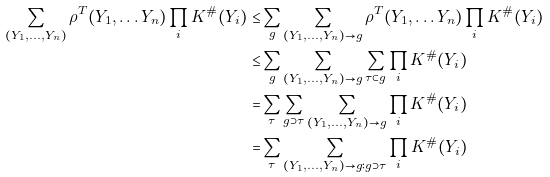Convert formula to latex. <formula><loc_0><loc_0><loc_500><loc_500>\sum _ { ( Y _ { 1 } , \dots , Y _ { n } ) } \rho ^ { T } ( Y _ { 1 } , \dots Y _ { n } ) \prod _ { i } K ^ { \# } ( Y _ { i } ) \leq & \sum _ { g } \sum _ { ( Y _ { 1 } , \dots , Y _ { n } ) \to g } \rho ^ { T } ( Y _ { 1 } , \dots Y _ { n } ) \prod _ { i } K ^ { \# } ( Y _ { i } ) \\ \leq & \sum _ { g } \sum _ { ( Y _ { 1 } , \dots , Y _ { n } ) \to g } \sum _ { \tau \subset g } \prod _ { i } K ^ { \# } ( Y _ { i } ) \\ = & \sum _ { \tau } \sum _ { g \supset \tau } \sum _ { ( Y _ { 1 } , \dots , Y _ { n } ) \to g } \prod _ { i } K ^ { \# } ( Y _ { i } ) \\ = & \sum _ { \tau } \sum _ { ( Y _ { 1 } , \dots , Y _ { n } ) \to g \colon g \supset \tau } \prod _ { i } K ^ { \# } ( Y _ { i } ) \\</formula> 